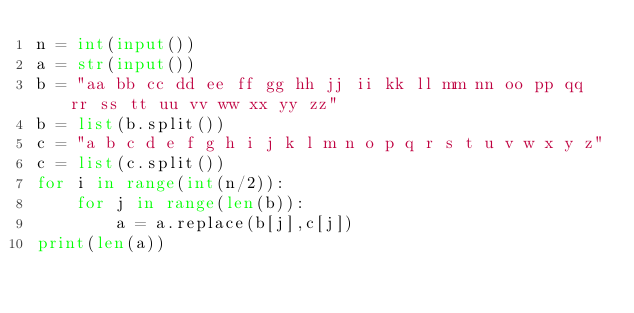Convert code to text. <code><loc_0><loc_0><loc_500><loc_500><_Python_>n = int(input())
a = str(input())
b = "aa bb cc dd ee ff gg hh jj ii kk ll mm nn oo pp qq rr ss tt uu vv ww xx yy zz"
b = list(b.split())
c = "a b c d e f g h i j k l m n o p q r s t u v w x y z"
c = list(c.split())
for i in range(int(n/2)):
    for j in range(len(b)):
        a = a.replace(b[j],c[j])
print(len(a))
    </code> 